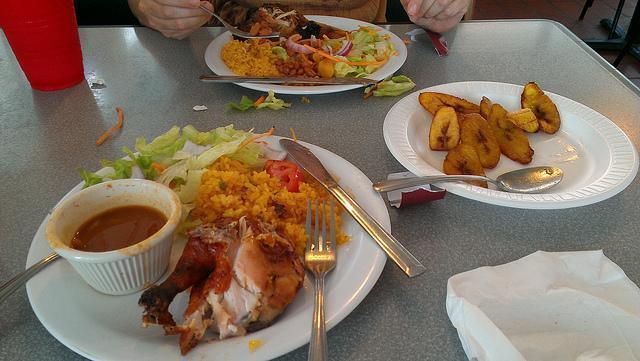What type of rice is on the dishes?
Select the accurate response from the four choices given to answer the question.
Options: Wild rice, spanish rice, brown rice, white rice. Spanish rice. 